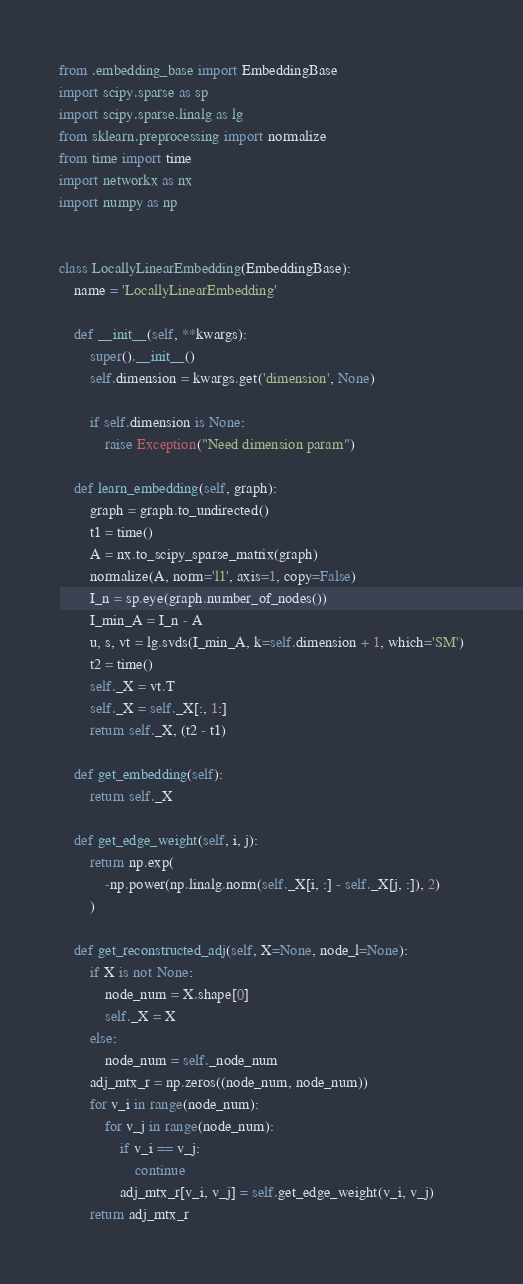Convert code to text. <code><loc_0><loc_0><loc_500><loc_500><_Python_>from .embedding_base import EmbeddingBase
import scipy.sparse as sp
import scipy.sparse.linalg as lg
from sklearn.preprocessing import normalize
from time import time
import networkx as nx
import numpy as np


class LocallyLinearEmbedding(EmbeddingBase):
    name = 'LocallyLinearEmbedding'

    def __init__(self, **kwargs):
        super().__init__()
        self.dimension = kwargs.get('dimension', None)

        if self.dimension is None:
            raise Exception("Need dimension param")

    def learn_embedding(self, graph):
        graph = graph.to_undirected()
        t1 = time()
        A = nx.to_scipy_sparse_matrix(graph)
        normalize(A, norm='l1', axis=1, copy=False)
        I_n = sp.eye(graph.number_of_nodes())
        I_min_A = I_n - A
        u, s, vt = lg.svds(I_min_A, k=self.dimension + 1, which='SM')
        t2 = time()
        self._X = vt.T
        self._X = self._X[:, 1:]
        return self._X, (t2 - t1)

    def get_embedding(self):
        return self._X

    def get_edge_weight(self, i, j):
        return np.exp(
            -np.power(np.linalg.norm(self._X[i, :] - self._X[j, :]), 2)
        )

    def get_reconstructed_adj(self, X=None, node_l=None):
        if X is not None:
            node_num = X.shape[0]
            self._X = X
        else:
            node_num = self._node_num
        adj_mtx_r = np.zeros((node_num, node_num))
        for v_i in range(node_num):
            for v_j in range(node_num):
                if v_i == v_j:
                    continue
                adj_mtx_r[v_i, v_j] = self.get_edge_weight(v_i, v_j)
        return adj_mtx_r
</code> 